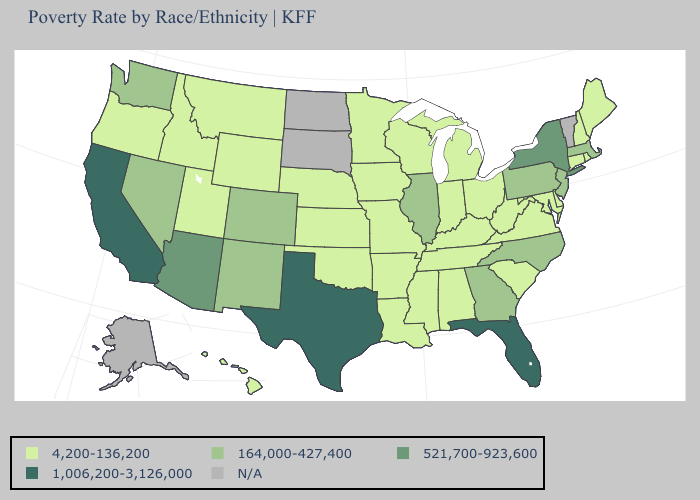Name the states that have a value in the range 1,006,200-3,126,000?
Give a very brief answer. California, Florida, Texas. What is the value of Delaware?
Give a very brief answer. 4,200-136,200. Which states have the highest value in the USA?
Short answer required. California, Florida, Texas. Among the states that border Kansas , does Colorado have the lowest value?
Give a very brief answer. No. Name the states that have a value in the range 521,700-923,600?
Keep it brief. Arizona, New York. What is the highest value in states that border Massachusetts?
Keep it brief. 521,700-923,600. Name the states that have a value in the range 4,200-136,200?
Keep it brief. Alabama, Arkansas, Connecticut, Delaware, Hawaii, Idaho, Indiana, Iowa, Kansas, Kentucky, Louisiana, Maine, Maryland, Michigan, Minnesota, Mississippi, Missouri, Montana, Nebraska, New Hampshire, Ohio, Oklahoma, Oregon, Rhode Island, South Carolina, Tennessee, Utah, Virginia, West Virginia, Wisconsin, Wyoming. How many symbols are there in the legend?
Keep it brief. 5. Does Texas have the highest value in the USA?
Be succinct. Yes. Does New York have the highest value in the USA?
Keep it brief. No. Name the states that have a value in the range 4,200-136,200?
Be succinct. Alabama, Arkansas, Connecticut, Delaware, Hawaii, Idaho, Indiana, Iowa, Kansas, Kentucky, Louisiana, Maine, Maryland, Michigan, Minnesota, Mississippi, Missouri, Montana, Nebraska, New Hampshire, Ohio, Oklahoma, Oregon, Rhode Island, South Carolina, Tennessee, Utah, Virginia, West Virginia, Wisconsin, Wyoming. Which states have the lowest value in the USA?
Write a very short answer. Alabama, Arkansas, Connecticut, Delaware, Hawaii, Idaho, Indiana, Iowa, Kansas, Kentucky, Louisiana, Maine, Maryland, Michigan, Minnesota, Mississippi, Missouri, Montana, Nebraska, New Hampshire, Ohio, Oklahoma, Oregon, Rhode Island, South Carolina, Tennessee, Utah, Virginia, West Virginia, Wisconsin, Wyoming. 